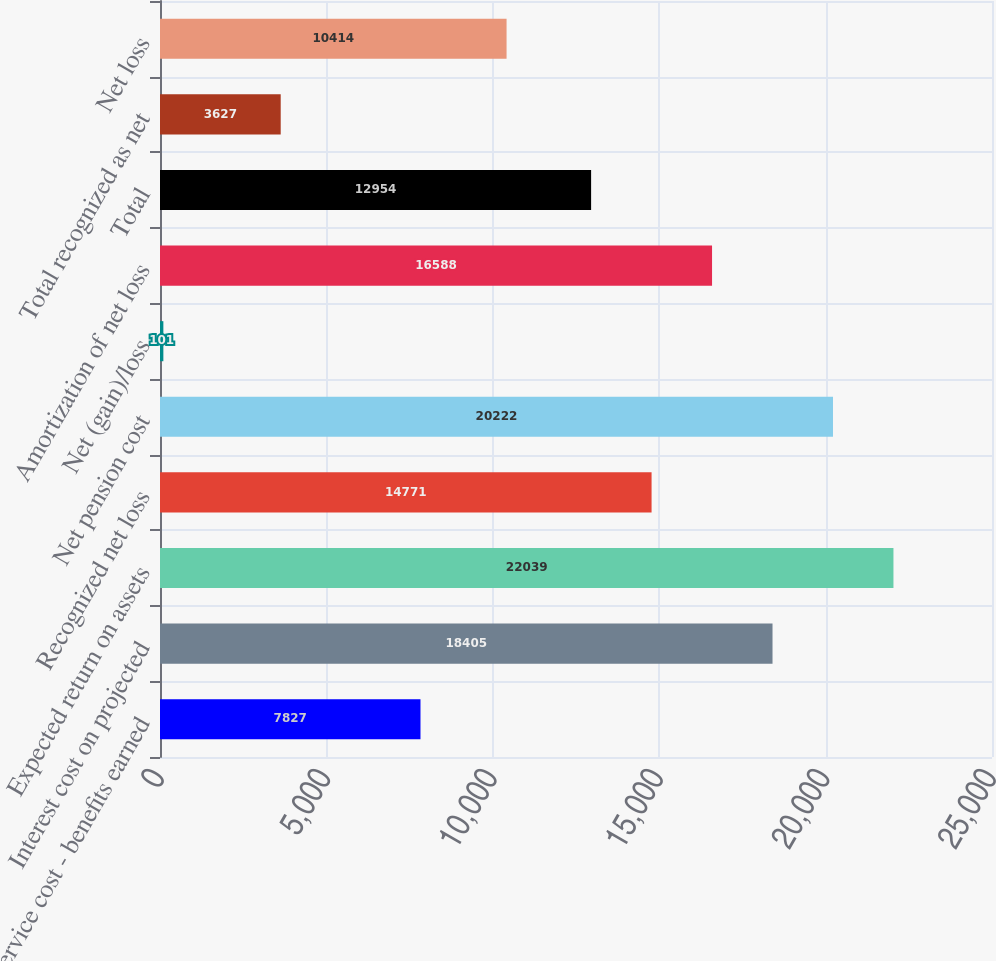<chart> <loc_0><loc_0><loc_500><loc_500><bar_chart><fcel>Service cost - benefits earned<fcel>Interest cost on projected<fcel>Expected return on assets<fcel>Recognized net loss<fcel>Net pension cost<fcel>Net (gain)/loss<fcel>Amortization of net loss<fcel>Total<fcel>Total recognized as net<fcel>Net loss<nl><fcel>7827<fcel>18405<fcel>22039<fcel>14771<fcel>20222<fcel>101<fcel>16588<fcel>12954<fcel>3627<fcel>10414<nl></chart> 